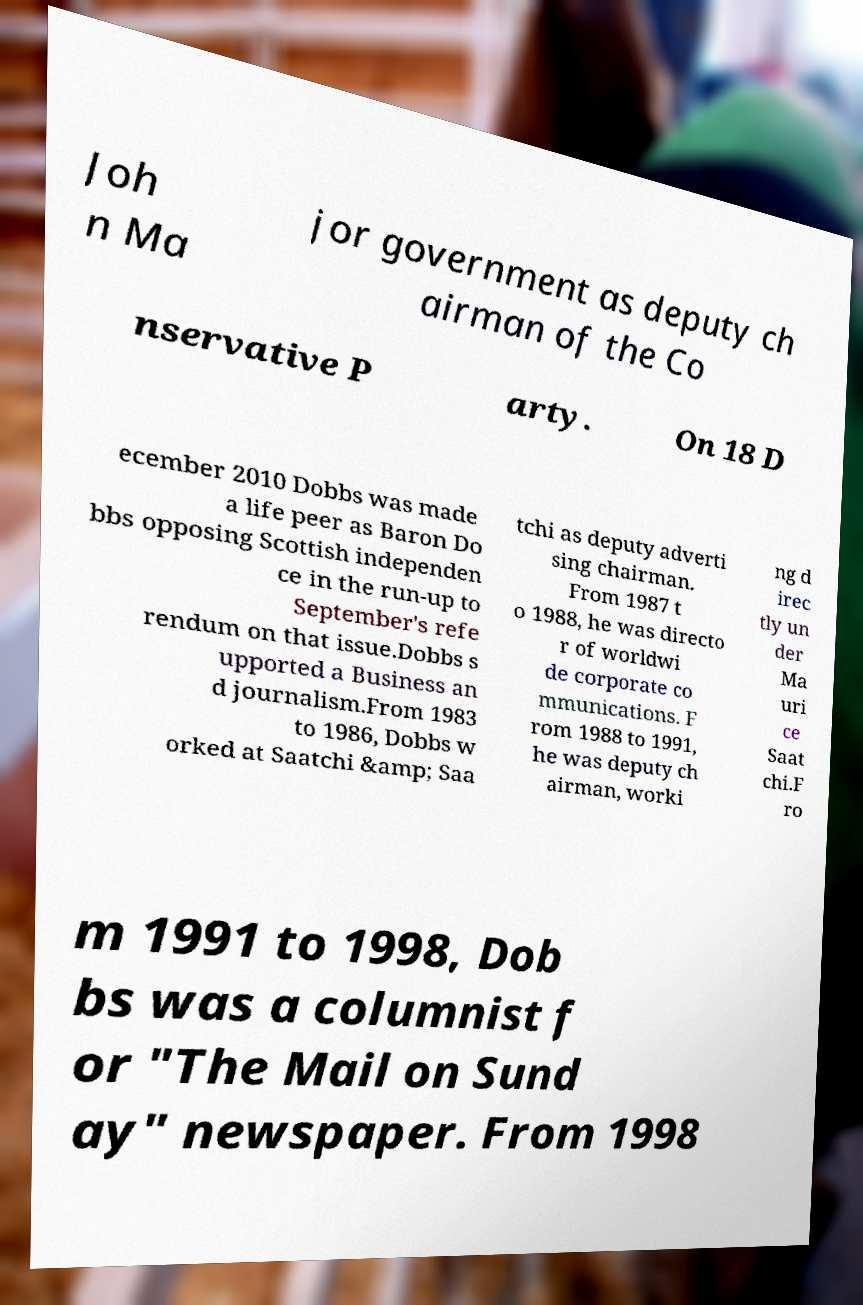What messages or text are displayed in this image? I need them in a readable, typed format. Joh n Ma jor government as deputy ch airman of the Co nservative P arty. On 18 D ecember 2010 Dobbs was made a life peer as Baron Do bbs opposing Scottish independen ce in the run-up to September's refe rendum on that issue.Dobbs s upported a Business an d journalism.From 1983 to 1986, Dobbs w orked at Saatchi &amp; Saa tchi as deputy adverti sing chairman. From 1987 t o 1988, he was directo r of worldwi de corporate co mmunications. F rom 1988 to 1991, he was deputy ch airman, worki ng d irec tly un der Ma uri ce Saat chi.F ro m 1991 to 1998, Dob bs was a columnist f or "The Mail on Sund ay" newspaper. From 1998 